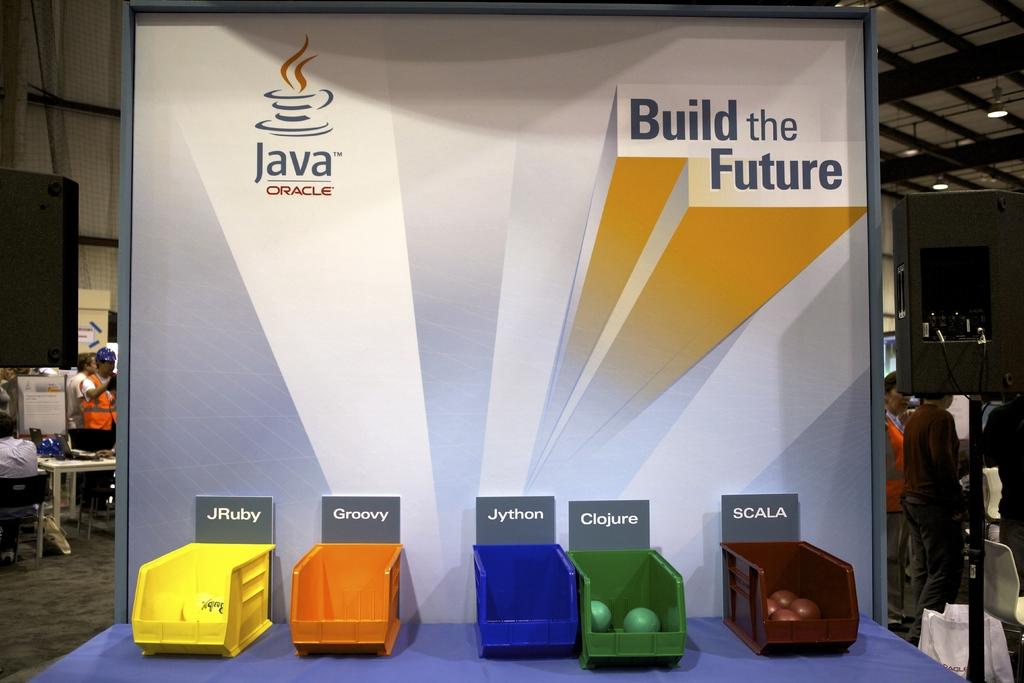What does the green bucket say?
Provide a short and direct response. Clojure. What are they building?
Your answer should be compact. The future. 